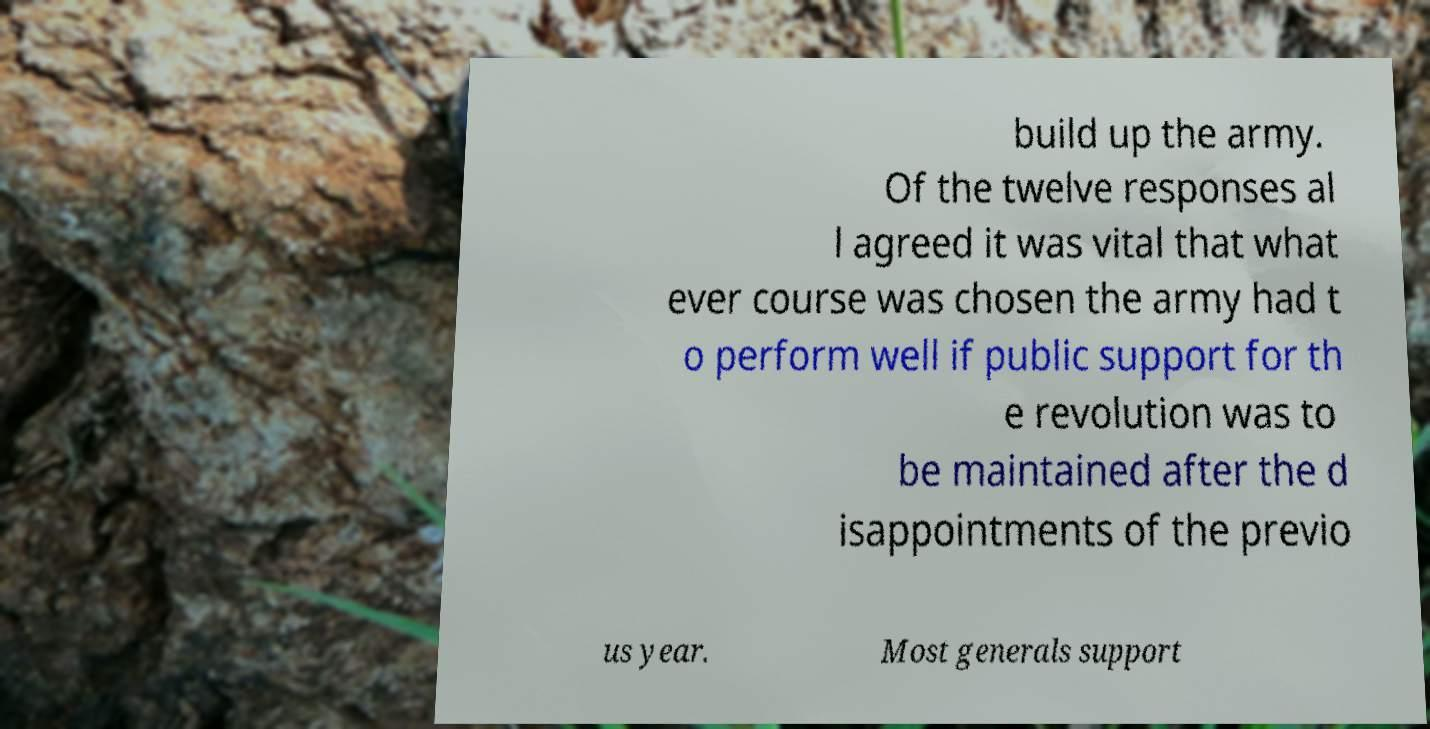For documentation purposes, I need the text within this image transcribed. Could you provide that? build up the army. Of the twelve responses al l agreed it was vital that what ever course was chosen the army had t o perform well if public support for th e revolution was to be maintained after the d isappointments of the previo us year. Most generals support 